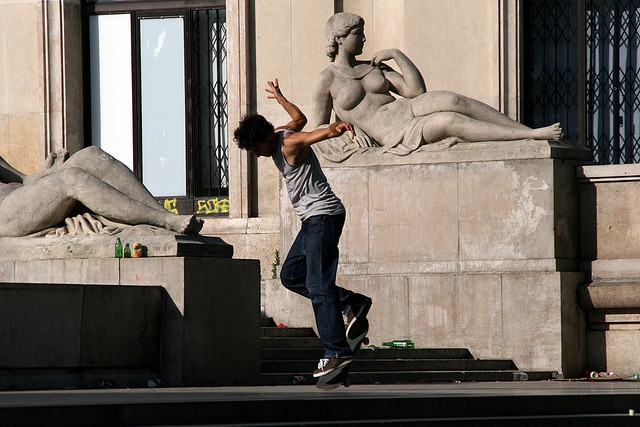Describe the objects in this image and their specific colors. I can see people in lightgray, black, darkgray, gray, and brown tones, skateboard in lightgray, black, and gray tones, bottle in lightgray, black, darkgreen, darkgray, and gray tones, bottle in lightgray, darkgreen, and black tones, and bottle in lightgray, black, olive, darkgray, and maroon tones in this image. 